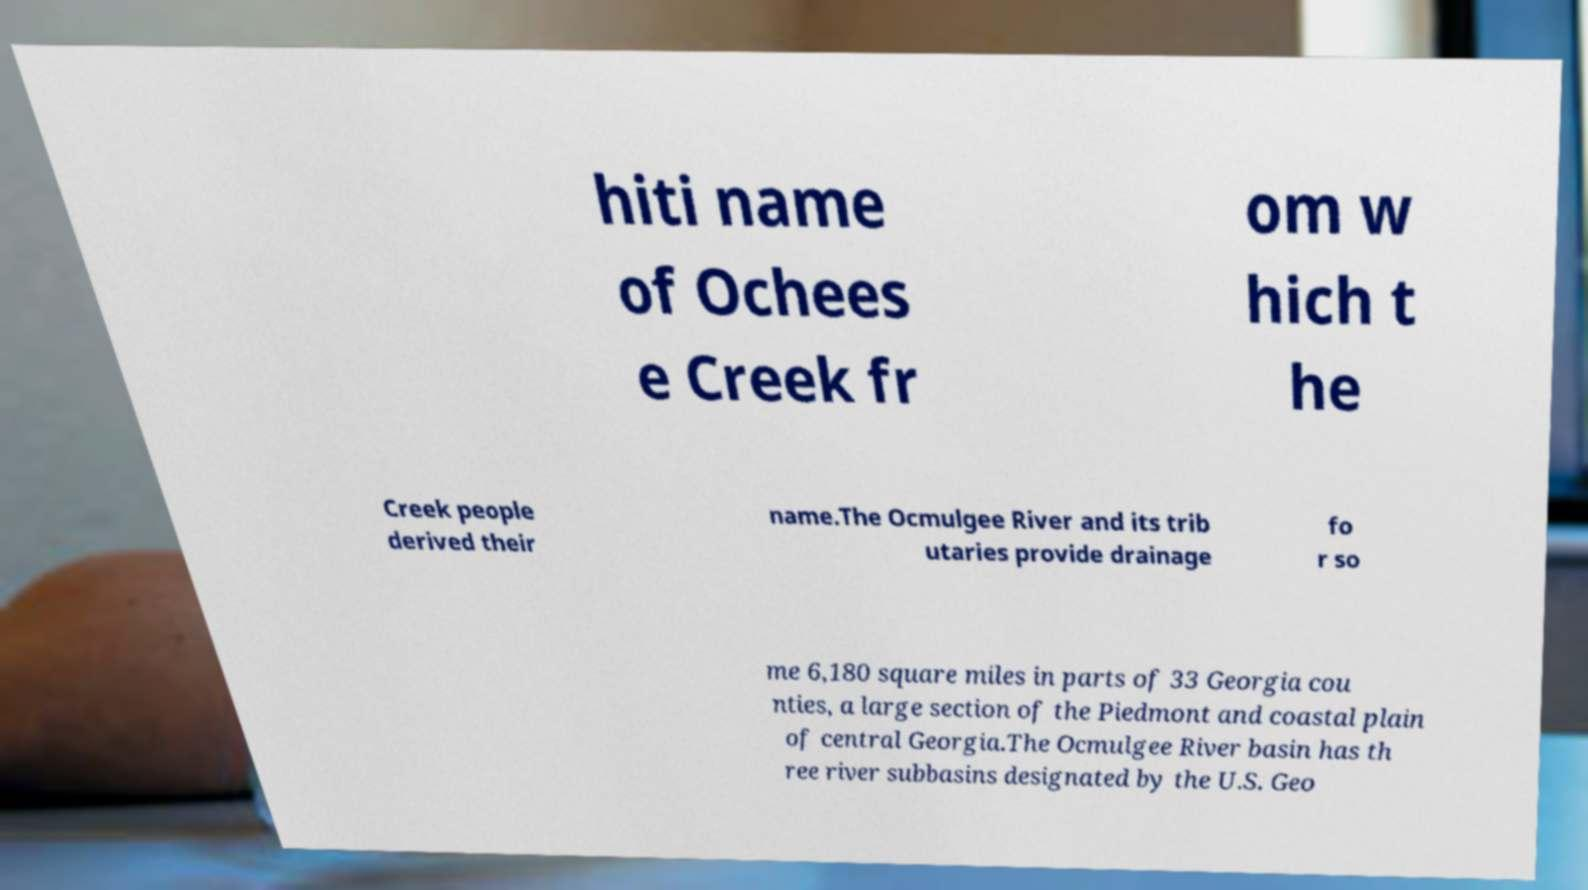Please identify and transcribe the text found in this image. hiti name of Ochees e Creek fr om w hich t he Creek people derived their name.The Ocmulgee River and its trib utaries provide drainage fo r so me 6,180 square miles in parts of 33 Georgia cou nties, a large section of the Piedmont and coastal plain of central Georgia.The Ocmulgee River basin has th ree river subbasins designated by the U.S. Geo 